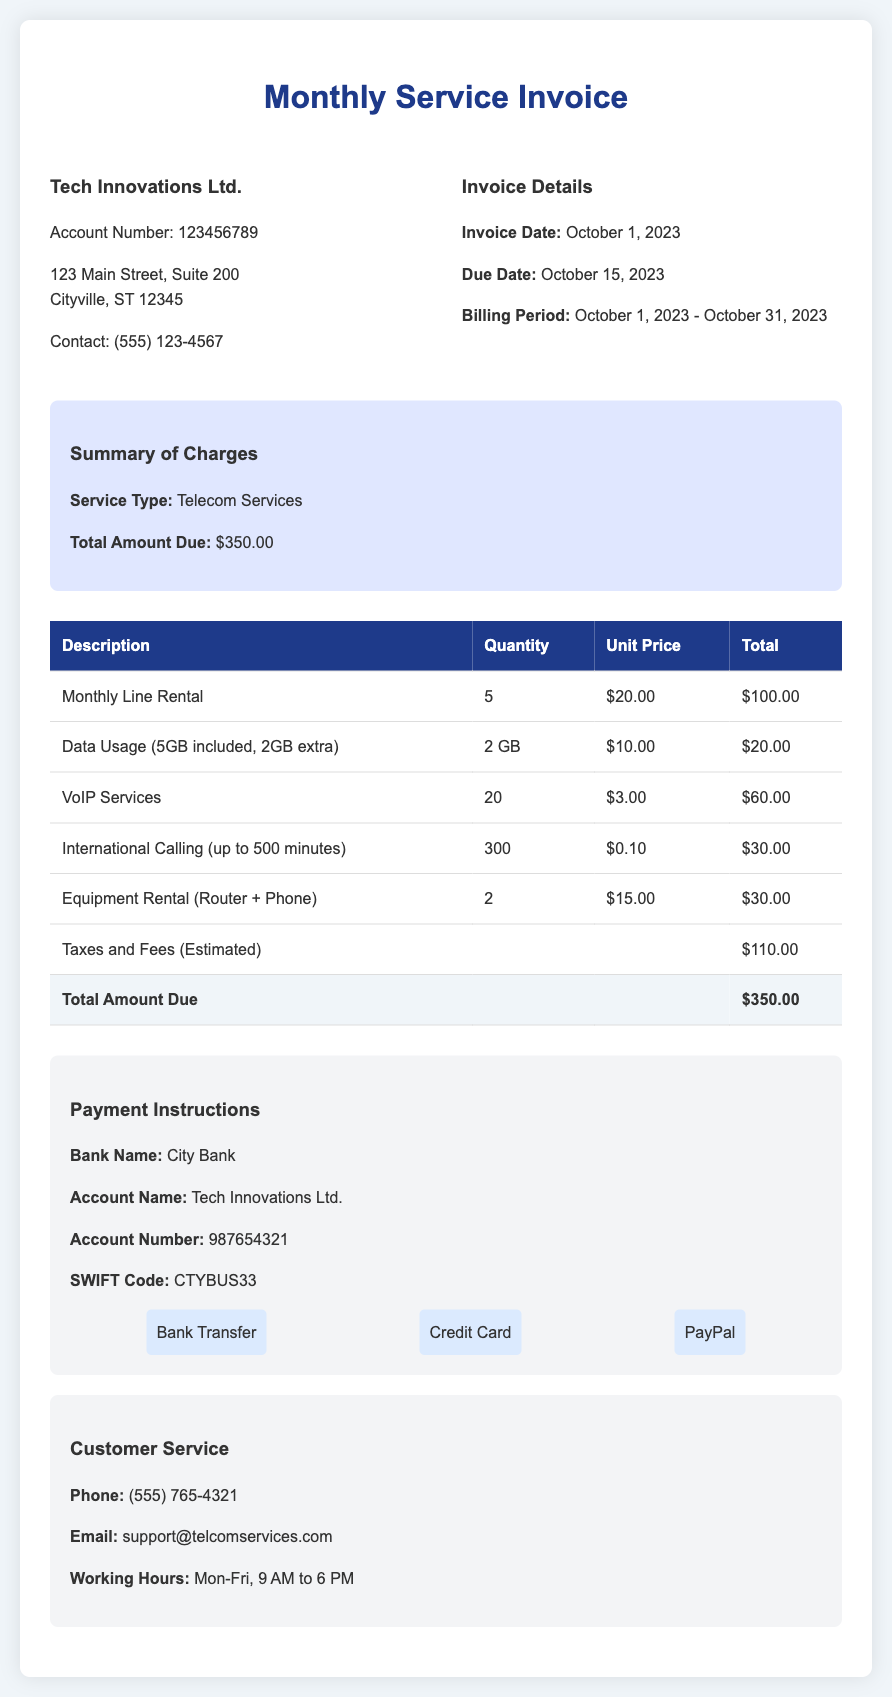What is the invoice date? The invoice date is found under the Invoice Details section, indicating when the invoice was generated.
Answer: October 1, 2023 What is the total amount due? The total amount due is listed in the Summary of Charges section, summarizing the charges for the month.
Answer: $350.00 How many VoIP services are included? The number of VoIP services is given in the charges breakdown, indicating the quantity of services billed.
Answer: 20 What are the payment methods available? Payment methods are mentioned in the Payment Instructions section, indicating how the customer can settle the invoice.
Answer: Bank Transfer, Credit Card, PayPal What is the billing period? The billing period is specified in the Invoice Details section, indicating the time frame for the charges listed in the invoice.
Answer: October 1, 2023 - October 31, 2023 How much is charged for equipment rental? The charge for equipment rental can be found in the detailed charges table, specifying the cost associated with this service.
Answer: $30.00 What is the customer service email address? The customer service email is provided in the Customer Service section, offering a means to contact support for inquiries.
Answer: support@telcomservices.com What is the estimated amount for taxes and fees? The amount for taxes and fees is highlighted in the charges breakdown, indicating expected additional costs.
Answer: $110.00 What is the account number for Tech Innovations Ltd.? The account number is listed in the client information section, which identifies the specific account for billing.
Answer: 123456789 